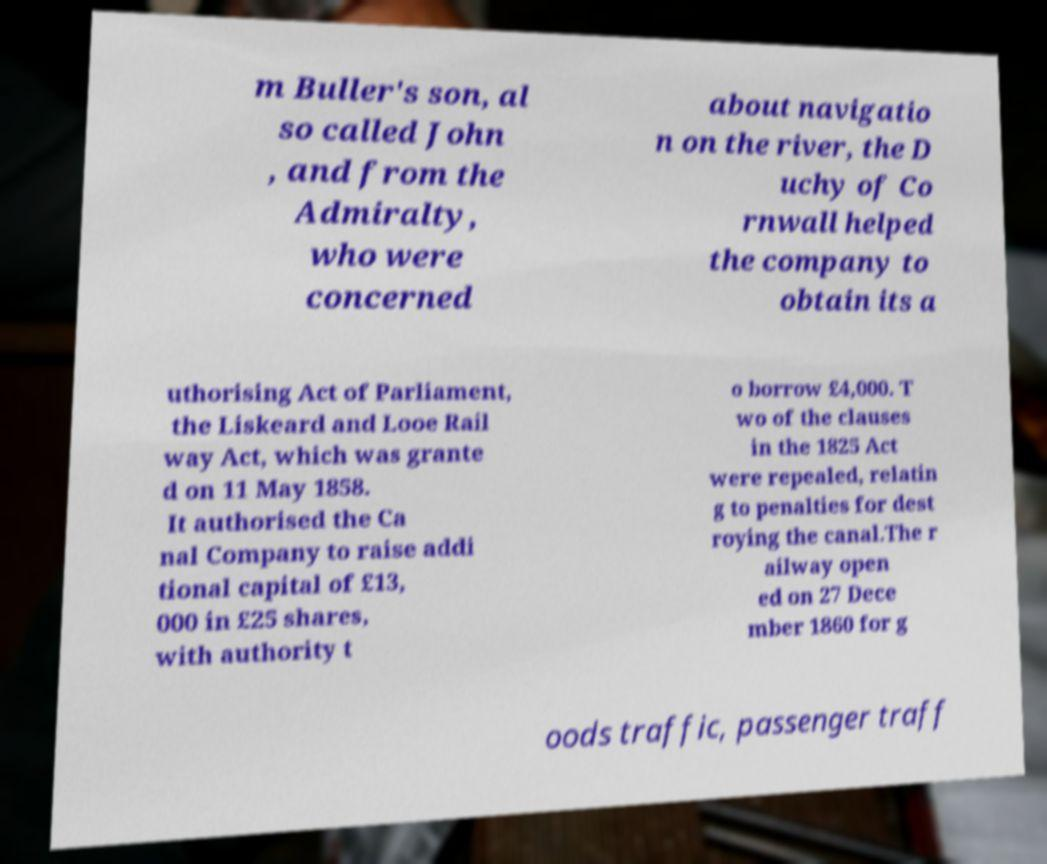Please identify and transcribe the text found in this image. m Buller's son, al so called John , and from the Admiralty, who were concerned about navigatio n on the river, the D uchy of Co rnwall helped the company to obtain its a uthorising Act of Parliament, the Liskeard and Looe Rail way Act, which was grante d on 11 May 1858. It authorised the Ca nal Company to raise addi tional capital of £13, 000 in £25 shares, with authority t o borrow £4,000. T wo of the clauses in the 1825 Act were repealed, relatin g to penalties for dest roying the canal.The r ailway open ed on 27 Dece mber 1860 for g oods traffic, passenger traff 